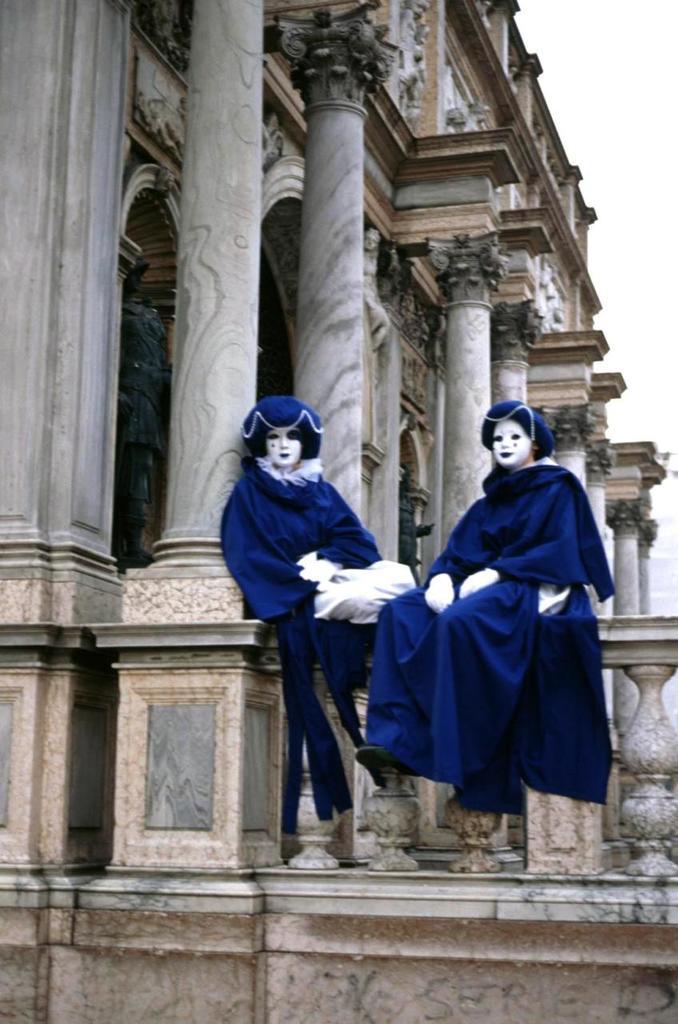Please provide a concise description of this image. In this picture I can see couple of them are wearing fancy dress and they are sitting on the wall and I can see building and I can see sky. 